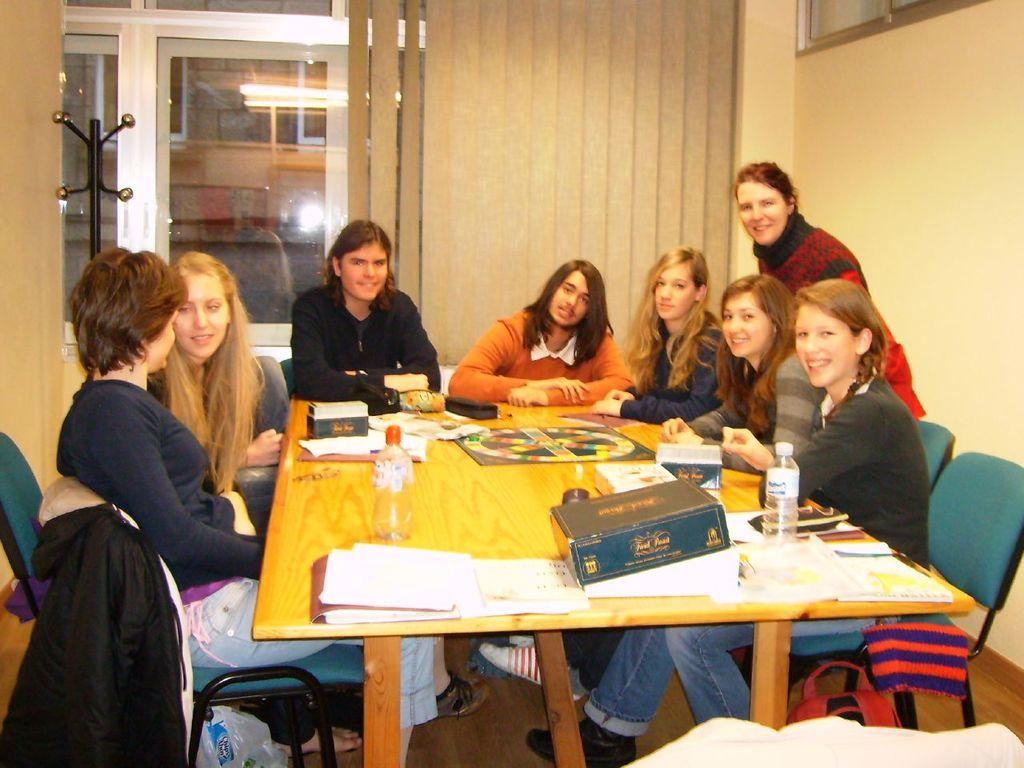What are the people in the image doing? The people in the image are sitting on chairs. What can be seen on the table in the image? There are bottles, papers, files, and other things on the table. What type of furniture is present in the image? There are chairs and a cupboard in the image. What is placed on one of the chairs? There is a jacket on one of the chairs. Can you see an airplane flying over the seashore in the image? No, there is no airplane or seashore present in the image. 